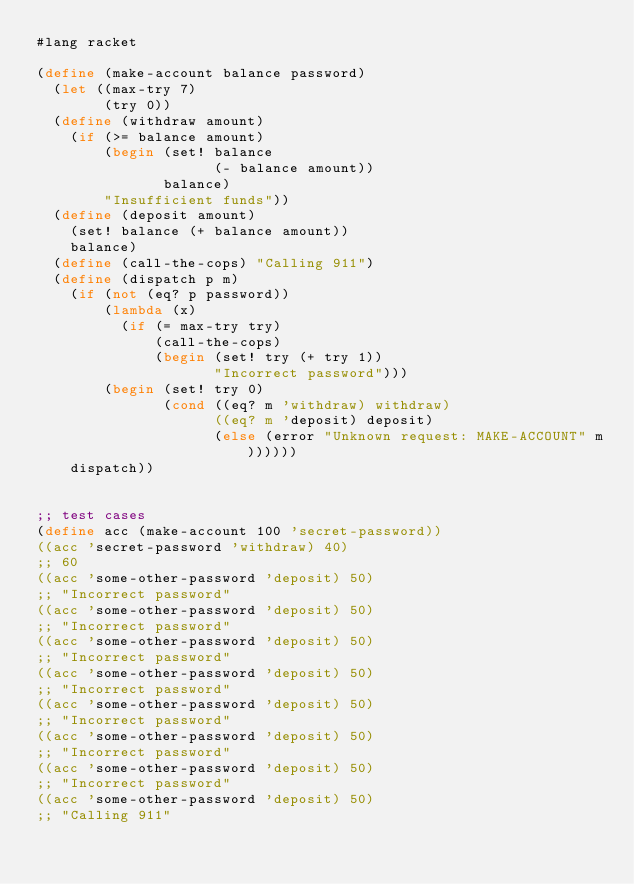Convert code to text. <code><loc_0><loc_0><loc_500><loc_500><_Scheme_>#lang racket

(define (make-account balance password)
  (let ((max-try 7)
        (try 0))
  (define (withdraw amount)
    (if (>= balance amount)
        (begin (set! balance 
                     (- balance amount))
               balance)
        "Insufficient funds"))
  (define (deposit amount)
    (set! balance (+ balance amount))
    balance)
  (define (call-the-cops) "Calling 911")
  (define (dispatch p m)
    (if (not (eq? p password)) 
        (lambda (x) 
          (if (= max-try try)
              (call-the-cops)
              (begin (set! try (+ try 1))
                     "Incorrect password")))
        (begin (set! try 0) 
               (cond ((eq? m 'withdraw) withdraw)
                     ((eq? m 'deposit) deposit)
                     (else (error "Unknown request: MAKE-ACCOUNT" m))))))
    dispatch))


;; test cases
(define acc (make-account 100 'secret-password))
((acc 'secret-password 'withdraw) 40)
;; 60
((acc 'some-other-password 'deposit) 50)
;; "Incorrect password"
((acc 'some-other-password 'deposit) 50)
;; "Incorrect password"
((acc 'some-other-password 'deposit) 50)
;; "Incorrect password"
((acc 'some-other-password 'deposit) 50)
;; "Incorrect password"
((acc 'some-other-password 'deposit) 50)
;; "Incorrect password"
((acc 'some-other-password 'deposit) 50)
;; "Incorrect password"
((acc 'some-other-password 'deposit) 50)
;; "Incorrect password"
((acc 'some-other-password 'deposit) 50)
;; "Calling 911"
</code> 